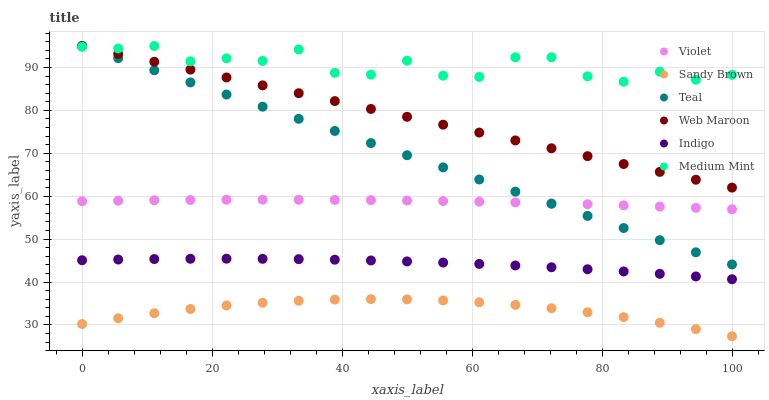Does Sandy Brown have the minimum area under the curve?
Answer yes or no. Yes. Does Medium Mint have the maximum area under the curve?
Answer yes or no. Yes. Does Indigo have the minimum area under the curve?
Answer yes or no. No. Does Indigo have the maximum area under the curve?
Answer yes or no. No. Is Web Maroon the smoothest?
Answer yes or no. Yes. Is Medium Mint the roughest?
Answer yes or no. Yes. Is Indigo the smoothest?
Answer yes or no. No. Is Indigo the roughest?
Answer yes or no. No. Does Sandy Brown have the lowest value?
Answer yes or no. Yes. Does Indigo have the lowest value?
Answer yes or no. No. Does Teal have the highest value?
Answer yes or no. Yes. Does Indigo have the highest value?
Answer yes or no. No. Is Indigo less than Violet?
Answer yes or no. Yes. Is Violet greater than Sandy Brown?
Answer yes or no. Yes. Does Medium Mint intersect Web Maroon?
Answer yes or no. Yes. Is Medium Mint less than Web Maroon?
Answer yes or no. No. Is Medium Mint greater than Web Maroon?
Answer yes or no. No. Does Indigo intersect Violet?
Answer yes or no. No. 